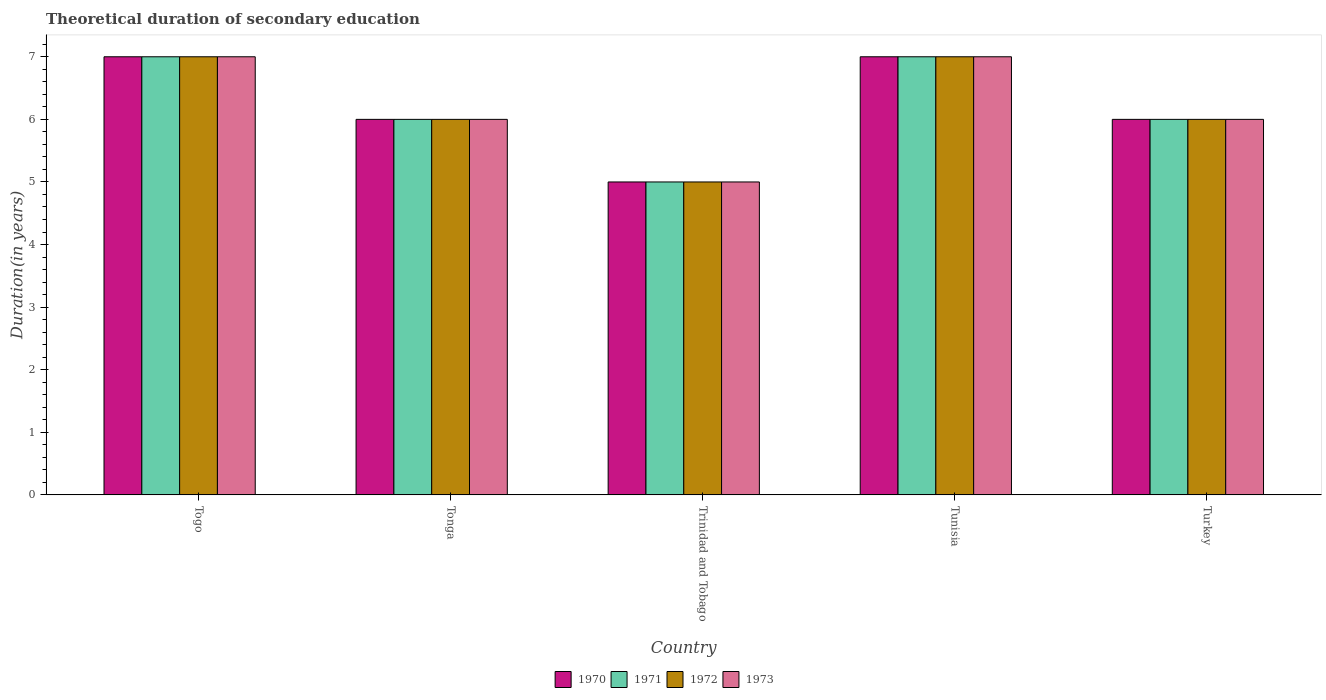Are the number of bars per tick equal to the number of legend labels?
Ensure brevity in your answer.  Yes. How many bars are there on the 1st tick from the left?
Keep it short and to the point. 4. What is the label of the 1st group of bars from the left?
Offer a very short reply. Togo. In how many cases, is the number of bars for a given country not equal to the number of legend labels?
Your response must be concise. 0. In which country was the total theoretical duration of secondary education in 1973 maximum?
Your answer should be very brief. Togo. In which country was the total theoretical duration of secondary education in 1972 minimum?
Your answer should be very brief. Trinidad and Tobago. What is the total total theoretical duration of secondary education in 1971 in the graph?
Make the answer very short. 31. What is the difference between the total theoretical duration of secondary education in 1972 in Togo and that in Tunisia?
Your answer should be very brief. 0. What is the difference between the total theoretical duration of secondary education in 1970 in Togo and the total theoretical duration of secondary education in 1972 in Tunisia?
Keep it short and to the point. 0. What is the average total theoretical duration of secondary education in 1972 per country?
Keep it short and to the point. 6.2. In how many countries, is the total theoretical duration of secondary education in 1970 greater than 5 years?
Your response must be concise. 4. What is the ratio of the total theoretical duration of secondary education in 1973 in Tunisia to that in Turkey?
Provide a short and direct response. 1.17. Is the total theoretical duration of secondary education in 1970 in Togo less than that in Tonga?
Your answer should be very brief. No. Is the difference between the total theoretical duration of secondary education in 1972 in Togo and Tunisia greater than the difference between the total theoretical duration of secondary education in 1970 in Togo and Tunisia?
Give a very brief answer. No. In how many countries, is the total theoretical duration of secondary education in 1971 greater than the average total theoretical duration of secondary education in 1971 taken over all countries?
Your answer should be compact. 2. Is it the case that in every country, the sum of the total theoretical duration of secondary education in 1971 and total theoretical duration of secondary education in 1972 is greater than the sum of total theoretical duration of secondary education in 1970 and total theoretical duration of secondary education in 1973?
Ensure brevity in your answer.  No. Is it the case that in every country, the sum of the total theoretical duration of secondary education in 1970 and total theoretical duration of secondary education in 1972 is greater than the total theoretical duration of secondary education in 1973?
Provide a short and direct response. Yes. Are all the bars in the graph horizontal?
Offer a very short reply. No. Where does the legend appear in the graph?
Your response must be concise. Bottom center. What is the title of the graph?
Ensure brevity in your answer.  Theoretical duration of secondary education. What is the label or title of the Y-axis?
Your answer should be compact. Duration(in years). What is the Duration(in years) in 1970 in Togo?
Provide a succinct answer. 7. What is the Duration(in years) of 1972 in Togo?
Your response must be concise. 7. What is the Duration(in years) in 1973 in Togo?
Ensure brevity in your answer.  7. What is the Duration(in years) in 1971 in Tonga?
Offer a very short reply. 6. What is the Duration(in years) of 1973 in Trinidad and Tobago?
Ensure brevity in your answer.  5. What is the Duration(in years) in 1970 in Tunisia?
Provide a succinct answer. 7. What is the Duration(in years) in 1972 in Tunisia?
Offer a terse response. 7. What is the Duration(in years) in 1971 in Turkey?
Your answer should be compact. 6. What is the Duration(in years) in 1973 in Turkey?
Provide a short and direct response. 6. Across all countries, what is the maximum Duration(in years) of 1971?
Your response must be concise. 7. Across all countries, what is the maximum Duration(in years) of 1972?
Your answer should be compact. 7. Across all countries, what is the maximum Duration(in years) in 1973?
Your answer should be very brief. 7. Across all countries, what is the minimum Duration(in years) of 1970?
Make the answer very short. 5. What is the difference between the Duration(in years) in 1970 in Togo and that in Tonga?
Give a very brief answer. 1. What is the difference between the Duration(in years) in 1971 in Togo and that in Tonga?
Make the answer very short. 1. What is the difference between the Duration(in years) of 1972 in Togo and that in Tonga?
Make the answer very short. 1. What is the difference between the Duration(in years) in 1971 in Togo and that in Trinidad and Tobago?
Offer a terse response. 2. What is the difference between the Duration(in years) in 1972 in Togo and that in Trinidad and Tobago?
Provide a succinct answer. 2. What is the difference between the Duration(in years) in 1970 in Togo and that in Tunisia?
Make the answer very short. 0. What is the difference between the Duration(in years) of 1970 in Togo and that in Turkey?
Your answer should be very brief. 1. What is the difference between the Duration(in years) in 1971 in Togo and that in Turkey?
Your answer should be very brief. 1. What is the difference between the Duration(in years) in 1972 in Togo and that in Turkey?
Offer a terse response. 1. What is the difference between the Duration(in years) in 1973 in Togo and that in Turkey?
Keep it short and to the point. 1. What is the difference between the Duration(in years) in 1970 in Tonga and that in Trinidad and Tobago?
Provide a short and direct response. 1. What is the difference between the Duration(in years) of 1973 in Tonga and that in Trinidad and Tobago?
Your answer should be compact. 1. What is the difference between the Duration(in years) in 1971 in Tonga and that in Tunisia?
Give a very brief answer. -1. What is the difference between the Duration(in years) of 1972 in Tonga and that in Tunisia?
Make the answer very short. -1. What is the difference between the Duration(in years) of 1971 in Tonga and that in Turkey?
Offer a very short reply. 0. What is the difference between the Duration(in years) in 1970 in Trinidad and Tobago and that in Tunisia?
Provide a succinct answer. -2. What is the difference between the Duration(in years) in 1972 in Trinidad and Tobago and that in Tunisia?
Your answer should be compact. -2. What is the difference between the Duration(in years) of 1970 in Trinidad and Tobago and that in Turkey?
Your answer should be very brief. -1. What is the difference between the Duration(in years) in 1971 in Trinidad and Tobago and that in Turkey?
Offer a very short reply. -1. What is the difference between the Duration(in years) of 1972 in Trinidad and Tobago and that in Turkey?
Offer a terse response. -1. What is the difference between the Duration(in years) of 1970 in Tunisia and that in Turkey?
Give a very brief answer. 1. What is the difference between the Duration(in years) of 1970 in Togo and the Duration(in years) of 1971 in Tonga?
Provide a succinct answer. 1. What is the difference between the Duration(in years) of 1971 in Togo and the Duration(in years) of 1972 in Tonga?
Make the answer very short. 1. What is the difference between the Duration(in years) in 1971 in Togo and the Duration(in years) in 1972 in Trinidad and Tobago?
Your response must be concise. 2. What is the difference between the Duration(in years) of 1972 in Togo and the Duration(in years) of 1973 in Trinidad and Tobago?
Offer a very short reply. 2. What is the difference between the Duration(in years) of 1970 in Togo and the Duration(in years) of 1973 in Tunisia?
Provide a short and direct response. 0. What is the difference between the Duration(in years) in 1972 in Togo and the Duration(in years) in 1973 in Tunisia?
Give a very brief answer. 0. What is the difference between the Duration(in years) in 1970 in Togo and the Duration(in years) in 1971 in Turkey?
Keep it short and to the point. 1. What is the difference between the Duration(in years) in 1970 in Togo and the Duration(in years) in 1972 in Turkey?
Make the answer very short. 1. What is the difference between the Duration(in years) in 1970 in Togo and the Duration(in years) in 1973 in Turkey?
Your answer should be compact. 1. What is the difference between the Duration(in years) in 1971 in Togo and the Duration(in years) in 1972 in Turkey?
Make the answer very short. 1. What is the difference between the Duration(in years) in 1970 in Tonga and the Duration(in years) in 1973 in Trinidad and Tobago?
Provide a short and direct response. 1. What is the difference between the Duration(in years) in 1970 in Tonga and the Duration(in years) in 1971 in Tunisia?
Your response must be concise. -1. What is the difference between the Duration(in years) of 1970 in Tonga and the Duration(in years) of 1972 in Tunisia?
Give a very brief answer. -1. What is the difference between the Duration(in years) in 1970 in Tonga and the Duration(in years) in 1973 in Turkey?
Ensure brevity in your answer.  0. What is the difference between the Duration(in years) of 1971 in Tonga and the Duration(in years) of 1972 in Turkey?
Offer a very short reply. 0. What is the difference between the Duration(in years) in 1972 in Tonga and the Duration(in years) in 1973 in Turkey?
Your response must be concise. 0. What is the difference between the Duration(in years) in 1970 in Trinidad and Tobago and the Duration(in years) in 1971 in Tunisia?
Ensure brevity in your answer.  -2. What is the difference between the Duration(in years) of 1970 in Trinidad and Tobago and the Duration(in years) of 1972 in Tunisia?
Make the answer very short. -2. What is the difference between the Duration(in years) in 1971 in Trinidad and Tobago and the Duration(in years) in 1973 in Tunisia?
Offer a terse response. -2. What is the difference between the Duration(in years) in 1971 in Trinidad and Tobago and the Duration(in years) in 1972 in Turkey?
Provide a succinct answer. -1. What is the difference between the Duration(in years) of 1970 in Tunisia and the Duration(in years) of 1972 in Turkey?
Offer a very short reply. 1. What is the difference between the Duration(in years) in 1971 in Tunisia and the Duration(in years) in 1972 in Turkey?
Give a very brief answer. 1. What is the difference between the Duration(in years) in 1971 in Tunisia and the Duration(in years) in 1973 in Turkey?
Offer a terse response. 1. What is the difference between the Duration(in years) of 1972 in Tunisia and the Duration(in years) of 1973 in Turkey?
Provide a succinct answer. 1. What is the average Duration(in years) of 1971 per country?
Give a very brief answer. 6.2. What is the difference between the Duration(in years) in 1972 and Duration(in years) in 1973 in Togo?
Make the answer very short. 0. What is the difference between the Duration(in years) of 1971 and Duration(in years) of 1972 in Tonga?
Make the answer very short. 0. What is the difference between the Duration(in years) in 1972 and Duration(in years) in 1973 in Tonga?
Make the answer very short. 0. What is the difference between the Duration(in years) of 1970 and Duration(in years) of 1972 in Trinidad and Tobago?
Your response must be concise. 0. What is the difference between the Duration(in years) of 1970 and Duration(in years) of 1972 in Tunisia?
Your response must be concise. 0. What is the difference between the Duration(in years) in 1970 and Duration(in years) in 1973 in Tunisia?
Provide a short and direct response. 0. What is the difference between the Duration(in years) of 1972 and Duration(in years) of 1973 in Tunisia?
Offer a very short reply. 0. What is the difference between the Duration(in years) of 1970 and Duration(in years) of 1971 in Turkey?
Your answer should be compact. 0. What is the difference between the Duration(in years) in 1972 and Duration(in years) in 1973 in Turkey?
Make the answer very short. 0. What is the ratio of the Duration(in years) of 1971 in Togo to that in Tonga?
Offer a terse response. 1.17. What is the ratio of the Duration(in years) in 1972 in Togo to that in Tonga?
Make the answer very short. 1.17. What is the ratio of the Duration(in years) of 1970 in Togo to that in Trinidad and Tobago?
Provide a short and direct response. 1.4. What is the ratio of the Duration(in years) of 1971 in Togo to that in Trinidad and Tobago?
Make the answer very short. 1.4. What is the ratio of the Duration(in years) in 1972 in Togo to that in Trinidad and Tobago?
Make the answer very short. 1.4. What is the ratio of the Duration(in years) in 1970 in Togo to that in Tunisia?
Ensure brevity in your answer.  1. What is the ratio of the Duration(in years) in 1973 in Togo to that in Tunisia?
Give a very brief answer. 1. What is the ratio of the Duration(in years) in 1973 in Togo to that in Turkey?
Provide a succinct answer. 1.17. What is the ratio of the Duration(in years) of 1972 in Tonga to that in Trinidad and Tobago?
Make the answer very short. 1.2. What is the ratio of the Duration(in years) in 1971 in Tonga to that in Tunisia?
Give a very brief answer. 0.86. What is the ratio of the Duration(in years) of 1973 in Tonga to that in Tunisia?
Keep it short and to the point. 0.86. What is the ratio of the Duration(in years) of 1970 in Tonga to that in Turkey?
Ensure brevity in your answer.  1. What is the ratio of the Duration(in years) in 1973 in Tonga to that in Turkey?
Ensure brevity in your answer.  1. What is the ratio of the Duration(in years) of 1972 in Trinidad and Tobago to that in Tunisia?
Give a very brief answer. 0.71. What is the ratio of the Duration(in years) in 1970 in Trinidad and Tobago to that in Turkey?
Give a very brief answer. 0.83. What is the ratio of the Duration(in years) of 1971 in Trinidad and Tobago to that in Turkey?
Give a very brief answer. 0.83. What is the ratio of the Duration(in years) in 1973 in Trinidad and Tobago to that in Turkey?
Give a very brief answer. 0.83. What is the ratio of the Duration(in years) in 1972 in Tunisia to that in Turkey?
Keep it short and to the point. 1.17. What is the difference between the highest and the second highest Duration(in years) in 1971?
Offer a very short reply. 0. What is the difference between the highest and the second highest Duration(in years) in 1972?
Offer a very short reply. 0. 